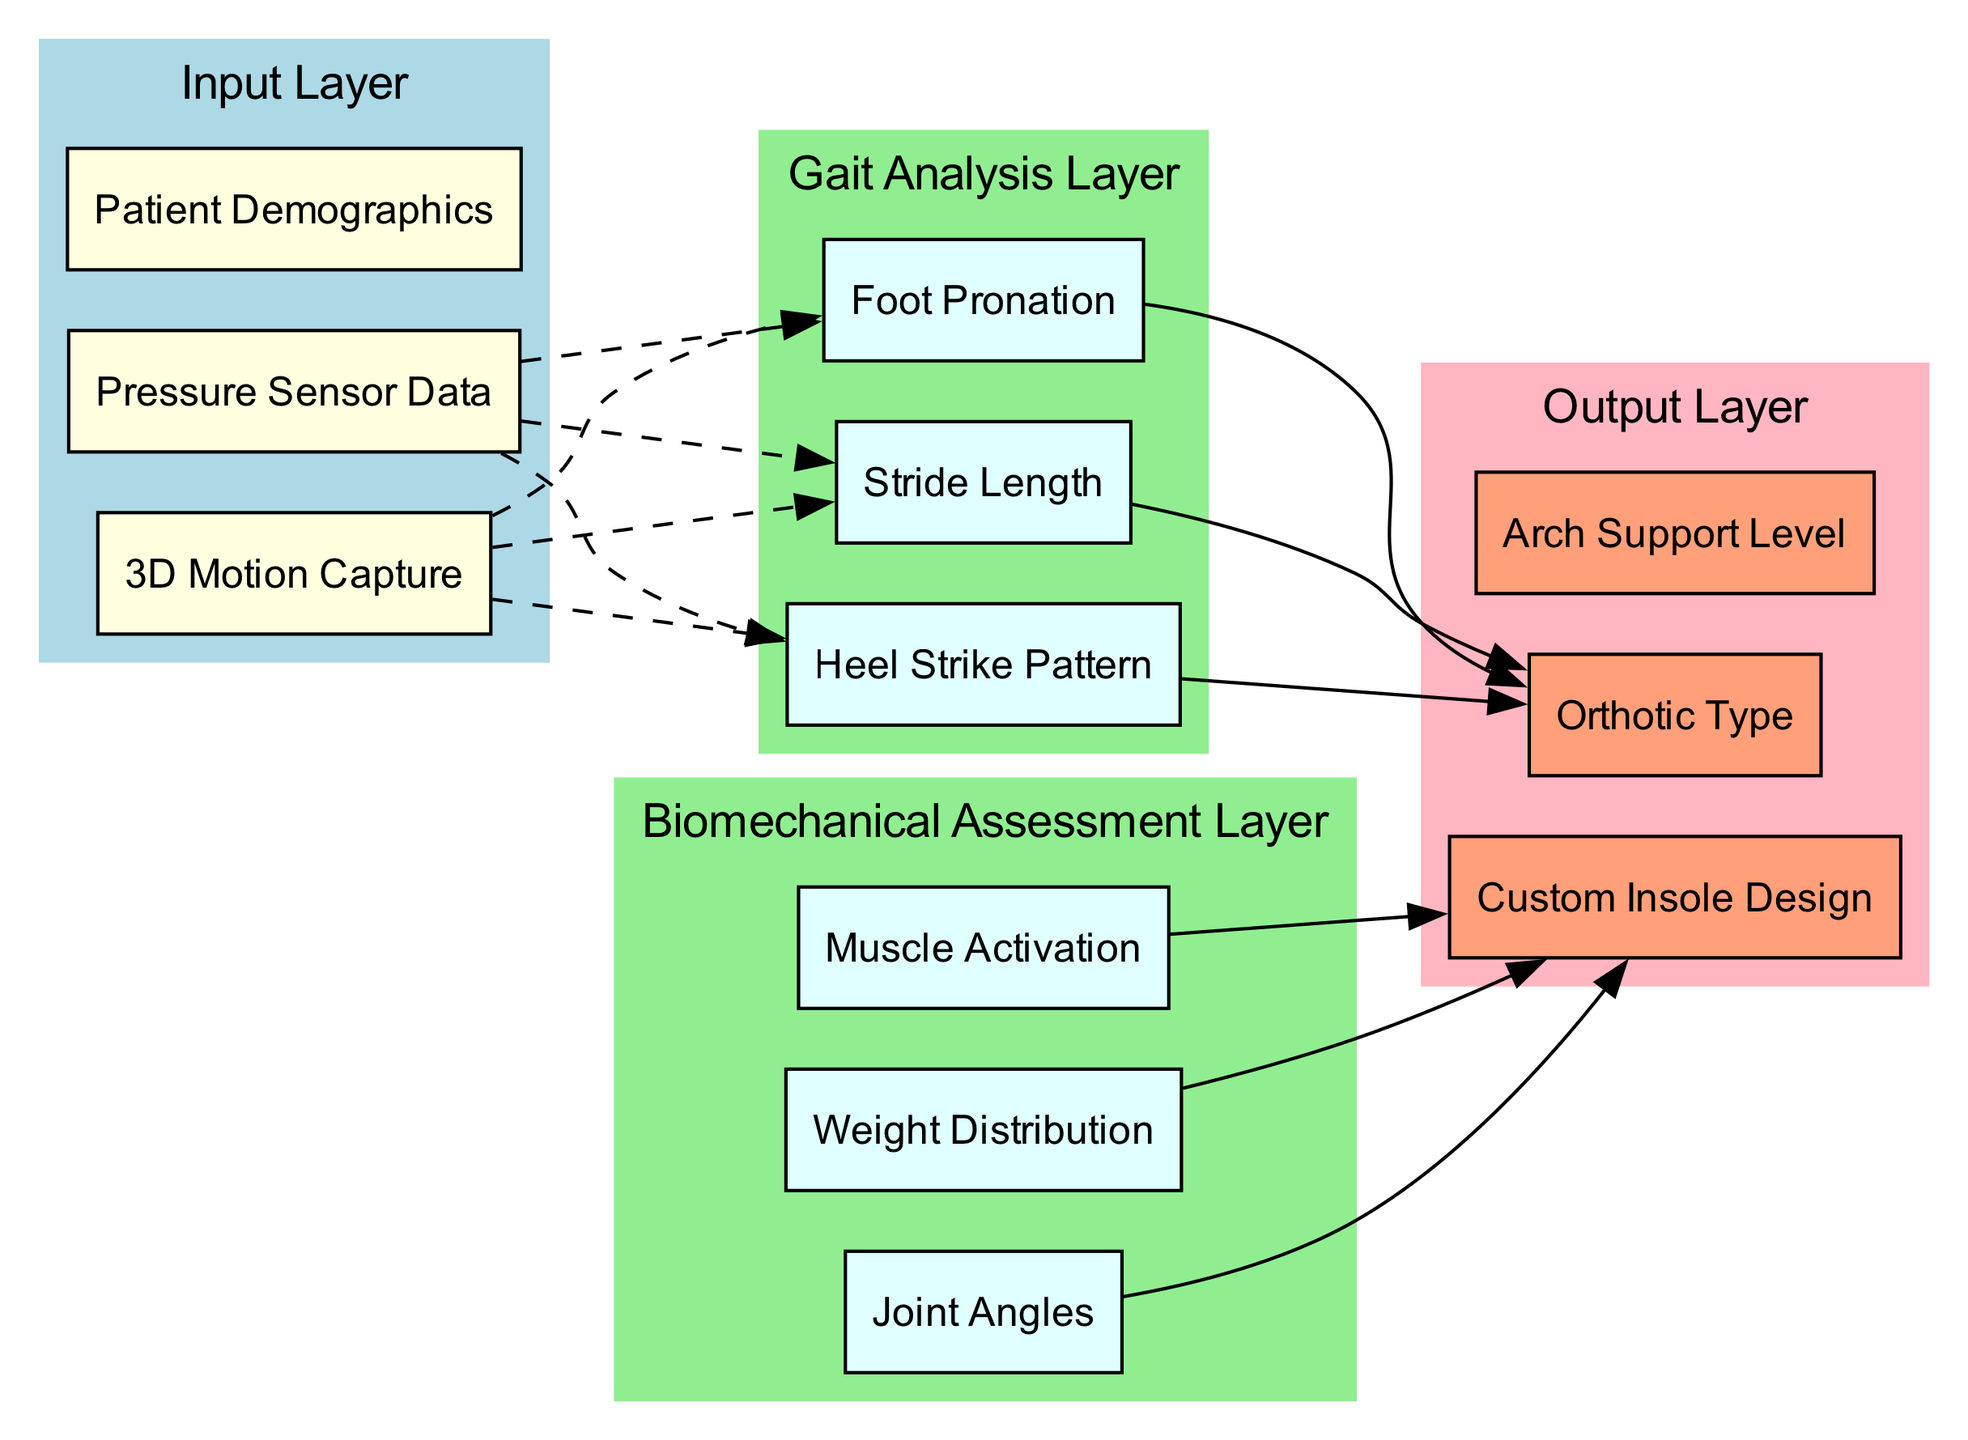What are the three input nodes? The input layer includes three nodes: "3D Motion Capture," "Pressure Sensor Data," and "Patient Demographics." By examining the "Input Layer" section in the diagram, we can clearly identify these three nodes representing the initial data sources.
Answer: 3D Motion Capture, Pressure Sensor Data, Patient Demographics How many hidden layers are there? The diagram presents two hidden layers: "Gait Analysis Layer" and "Biomechanical Assessment Layer." We can count the subgraphs represented in the hidden section to determine that there are two distinct layers.
Answer: 2 What type of data connects to the Gait Analysis Layer? The Gait Analysis Layer receives input data specifically from "3D Motion Capture," as indicated by the dashed edge connecting these two nodes in the diagram. The connection visualizes the flow of data into this layer.
Answer: 3D Motion Capture Which node outputs information about the Arch Support Level? The "Arch Support Level" is an output node in the Output Layer section, receiving its information from the Gait Analysis Layer. We can refer to the diagram to see that this node is clearly listed and connected appropriately.
Answer: Arch Support Level What nodes comprise the Biomechanical Assessment Layer? The Biomechanical Assessment Layer includes three nodes: "Joint Angles," "Weight Distribution," and "Muscle Activation." By reviewing the nodes listed under this layer in the diagram, we can easily identify them.
Answer: Joint Angles, Weight Distribution, Muscle Activation Which output node is influenced by data from the Biomechanical Assessment Layer? The "Custom Insole Design" output node is influenced by the Biomechanical Assessment Layer, as indicated by the solid edge connecting these two nodes. This shows that data flows from the hidden layer to this specific output.
Answer: Custom Insole Design How many total nodes are there in the entire diagram? There are a total of eight nodes in the diagram: three input nodes, three hidden layer nodes from each hidden layer, and two output nodes. Counting each node in the input, hidden, and output sections gives us this total.
Answer: 8 What is the relationship between "Foot Pronation" and "Orthotic Type"? "Foot Pronation" is part of the Gait Analysis Layer, and it influences the "Orthotic Type" in the Output Layer. The solid edge connecting these nodes illustrates that output decisions on orthotics are informed by the analysis of gait characteristics, such as foot pronation.
Answer: Influential relationship 